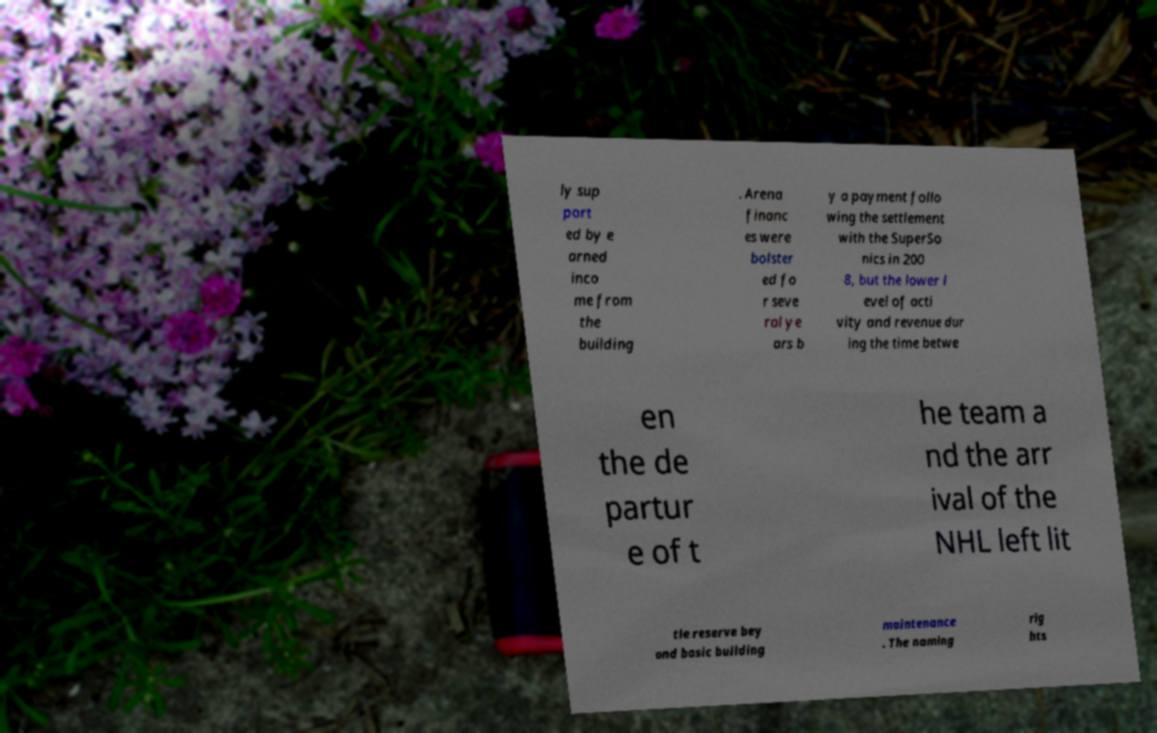Could you assist in decoding the text presented in this image and type it out clearly? ly sup port ed by e arned inco me from the building . Arena financ es were bolster ed fo r seve ral ye ars b y a payment follo wing the settlement with the SuperSo nics in 200 8, but the lower l evel of acti vity and revenue dur ing the time betwe en the de partur e of t he team a nd the arr ival of the NHL left lit tle reserve bey ond basic building maintenance . The naming rig hts 